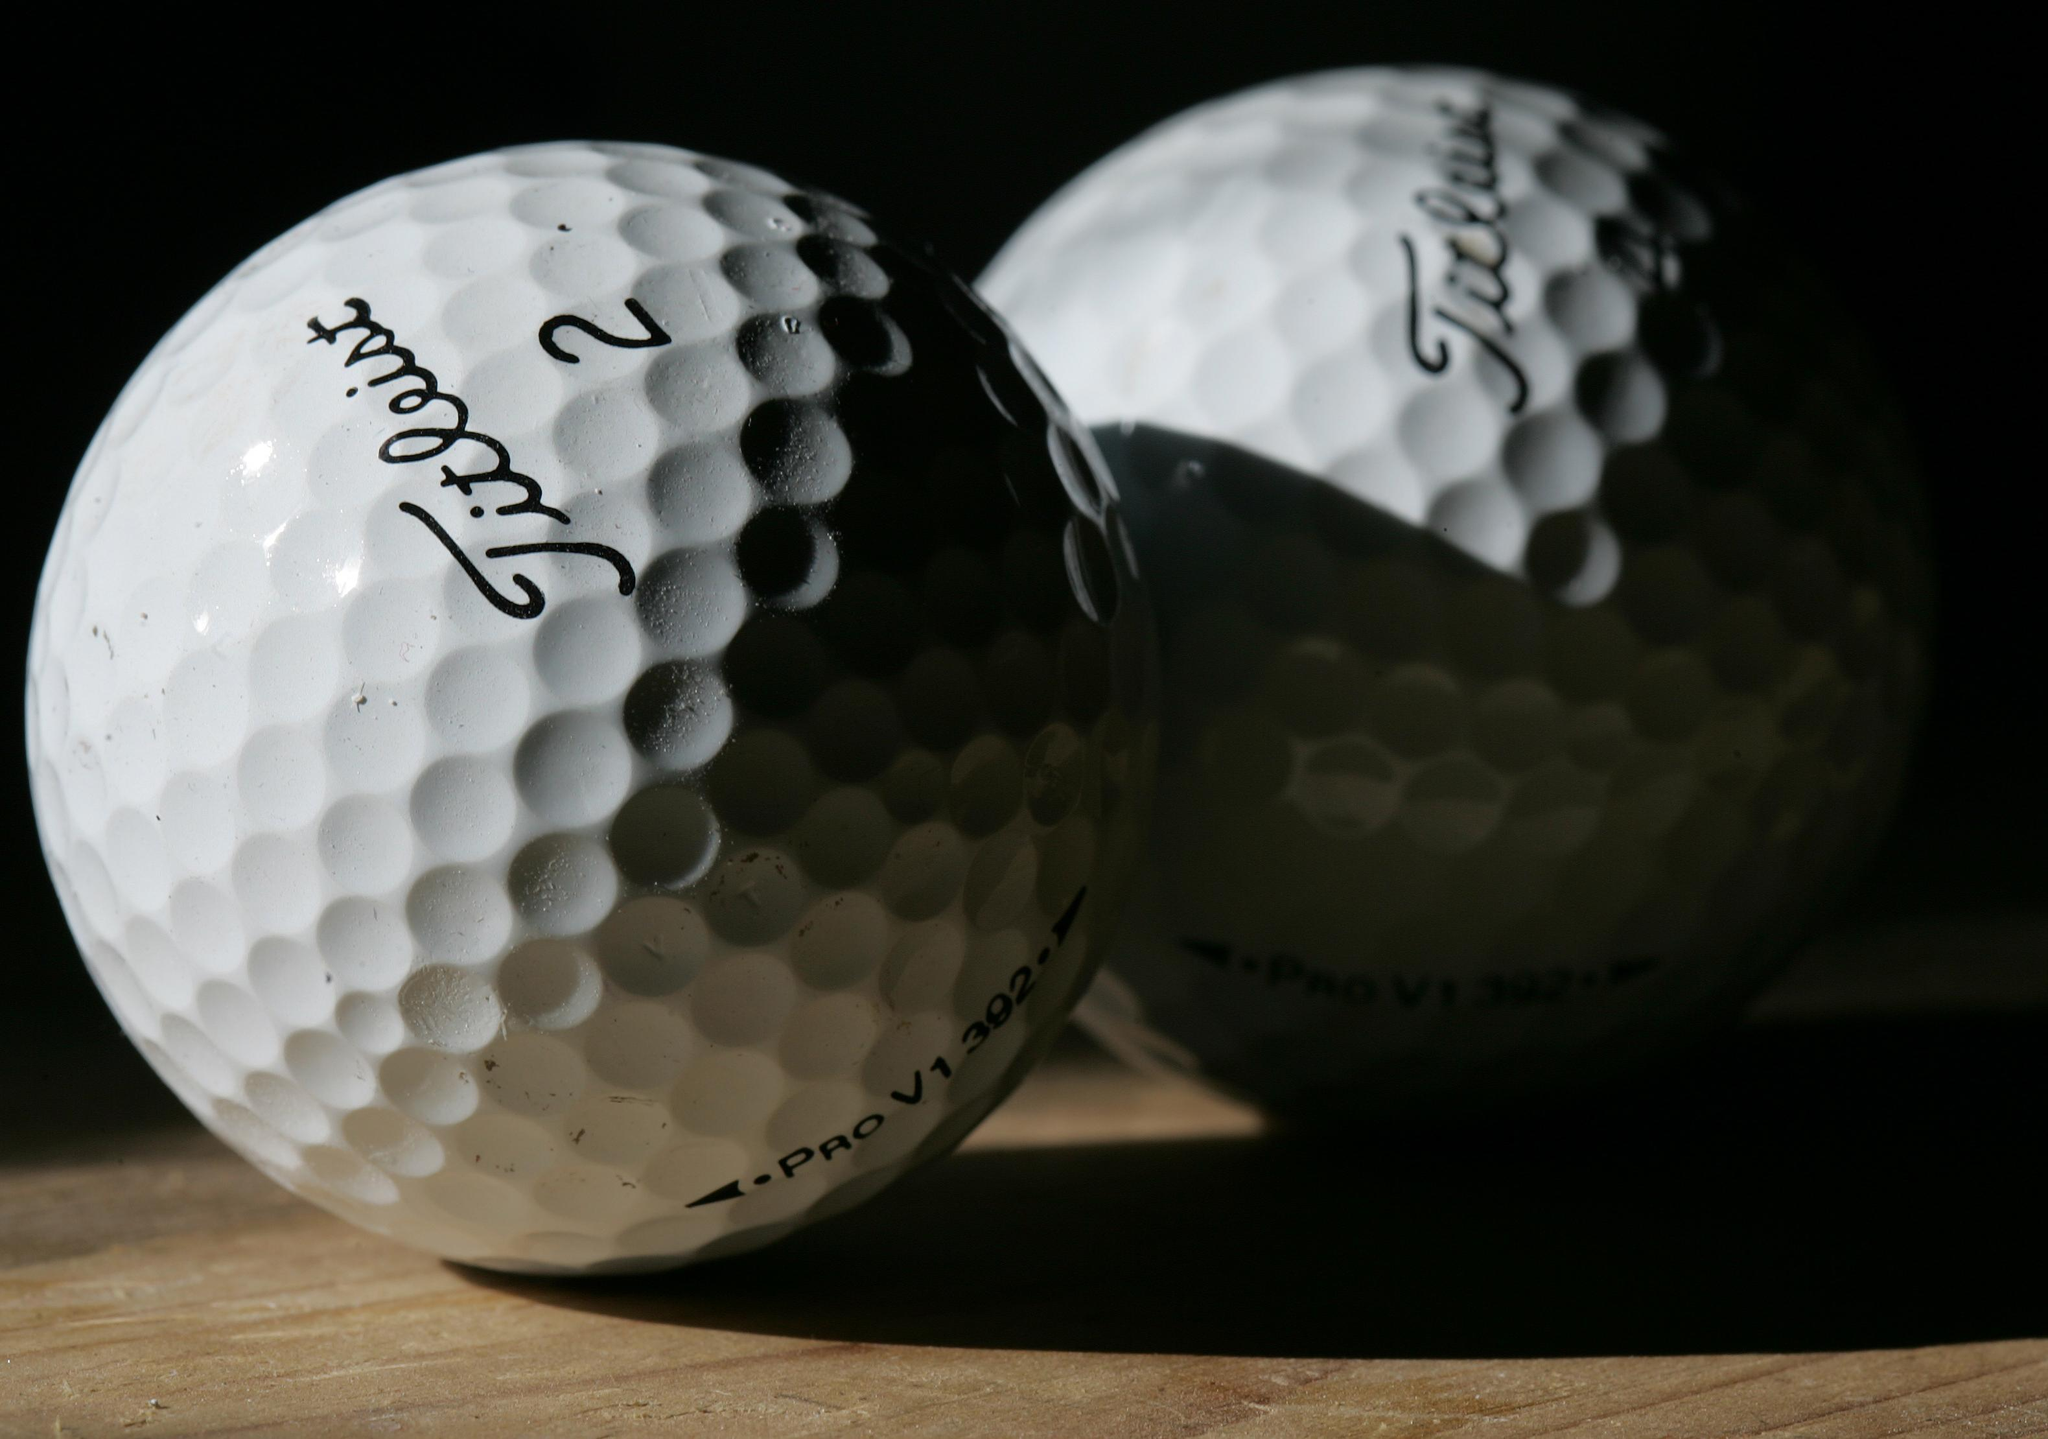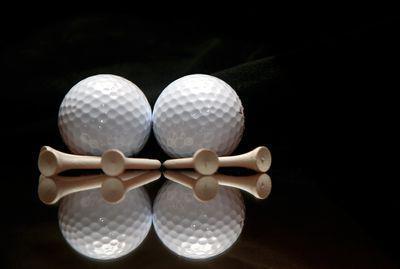The first image is the image on the left, the second image is the image on the right. Considering the images on both sides, is "The right image includes at least one golf tee, and the left image shows a pair of balls side-by-side." valid? Answer yes or no. Yes. The first image is the image on the left, the second image is the image on the right. For the images shown, is this caption "The right image contains exactly two golf balls." true? Answer yes or no. Yes. 